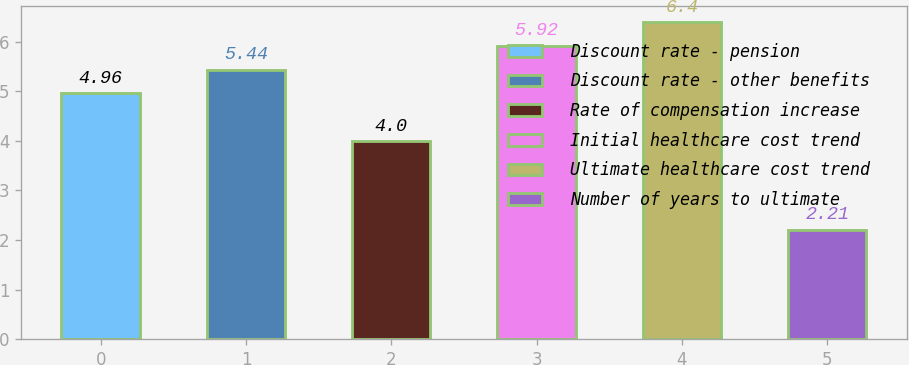Convert chart to OTSL. <chart><loc_0><loc_0><loc_500><loc_500><bar_chart><fcel>Discount rate - pension<fcel>Discount rate - other benefits<fcel>Rate of compensation increase<fcel>Initial healthcare cost trend<fcel>Ultimate healthcare cost trend<fcel>Number of years to ultimate<nl><fcel>4.96<fcel>5.44<fcel>4<fcel>5.92<fcel>6.4<fcel>2.21<nl></chart> 